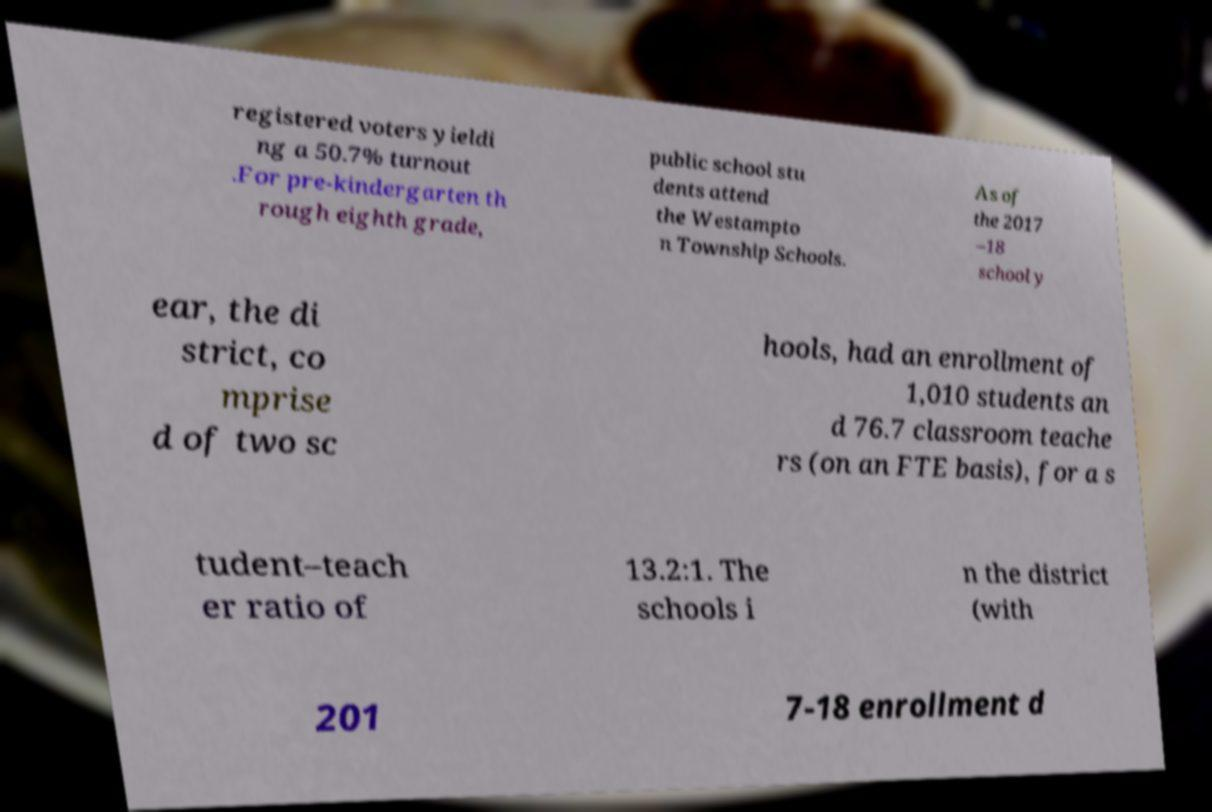There's text embedded in this image that I need extracted. Can you transcribe it verbatim? registered voters yieldi ng a 50.7% turnout .For pre-kindergarten th rough eighth grade, public school stu dents attend the Westampto n Township Schools. As of the 2017 –18 school y ear, the di strict, co mprise d of two sc hools, had an enrollment of 1,010 students an d 76.7 classroom teache rs (on an FTE basis), for a s tudent–teach er ratio of 13.2:1. The schools i n the district (with 201 7-18 enrollment d 